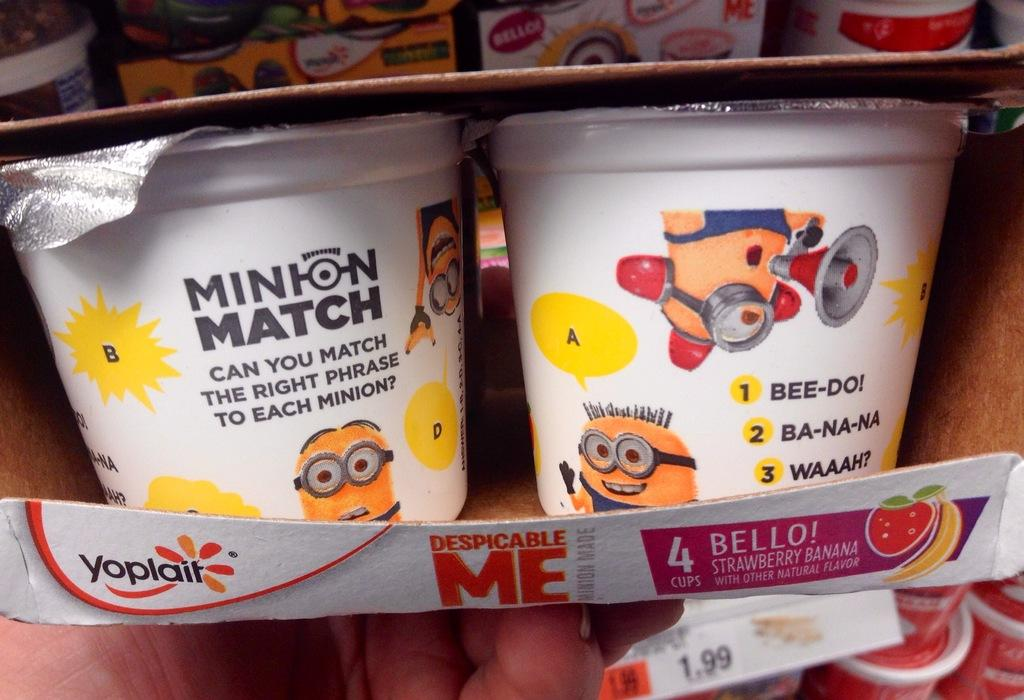What objects are inside the box in the image? There are two cups in a box in the image. Can you describe the surrounding area in the image? There are additional boxes and cups in the background of the image. Is there any information about the cost of the items in the image? Yes, a price tag is visible in the image. How many mice can be seen playing on the sand in the image? There are no mice or sand present in the image. Is there an island visible in the background of the image? No, there is no island visible in the image. 